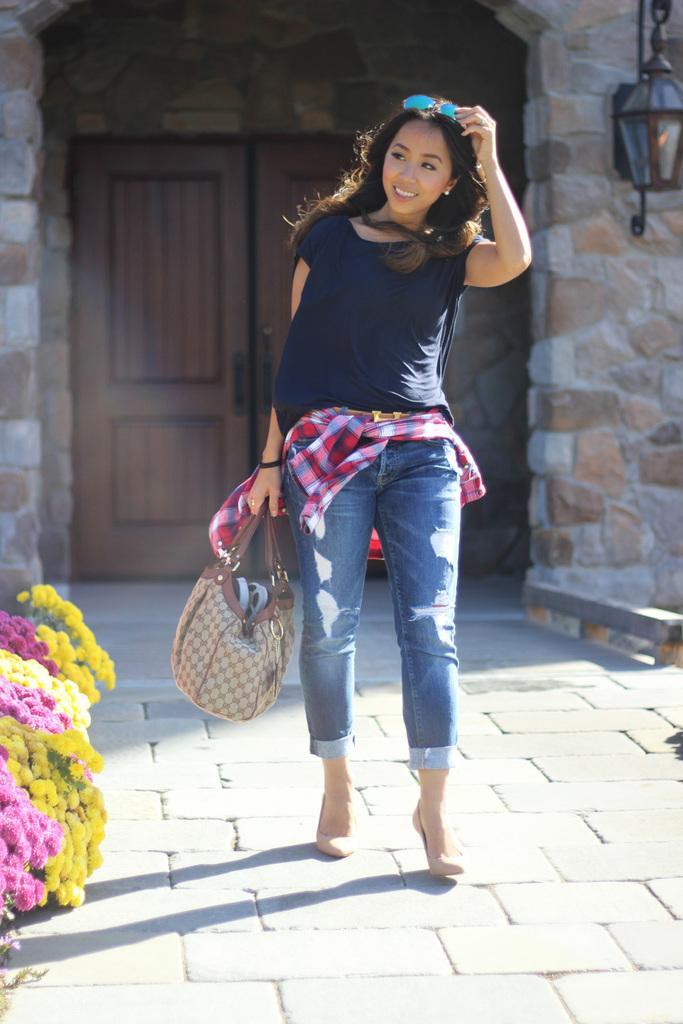In one or two sentences, can you explain what this image depicts? This picture shows a woman walking with a smile on her face and she holds a hand bag in her hand and we see few flowers on the side and we see a door back of her 